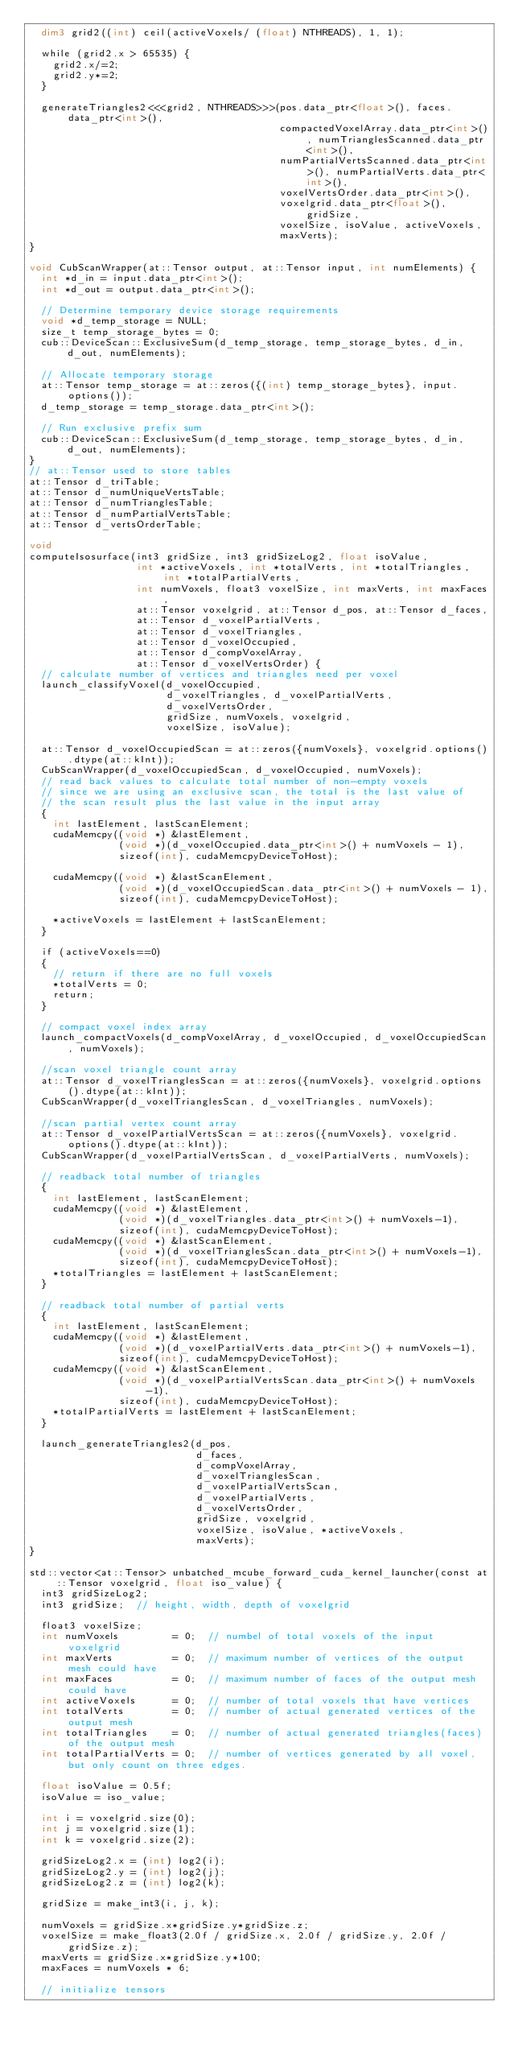Convert code to text. <code><loc_0><loc_0><loc_500><loc_500><_Cuda_>  dim3 grid2((int) ceil(activeVoxels/ (float) NTHREADS), 1, 1);

  while (grid2.x > 65535) {
    grid2.x/=2;
    grid2.y*=2;
  }

  generateTriangles2<<<grid2, NTHREADS>>>(pos.data_ptr<float>(), faces.data_ptr<int>(),
                                          compactedVoxelArray.data_ptr<int>(), numTrianglesScanned.data_ptr<int>(),
                                          numPartialVertsScanned.data_ptr<int>(), numPartialVerts.data_ptr<int>(),
                                          voxelVertsOrder.data_ptr<int>(),
                                          voxelgrid.data_ptr<float>(), gridSize,
                                          voxelSize, isoValue, activeVoxels,
                                          maxVerts);
}

void CubScanWrapper(at::Tensor output, at::Tensor input, int numElements) {
  int *d_in = input.data_ptr<int>();
  int *d_out = output.data_ptr<int>();

  // Determine temporary device storage requirements
  void *d_temp_storage = NULL;
  size_t temp_storage_bytes = 0;
  cub::DeviceScan::ExclusiveSum(d_temp_storage, temp_storage_bytes, d_in, d_out, numElements);

  // Allocate temporary storage
  at::Tensor temp_storage = at::zeros({(int) temp_storage_bytes}, input.options());
  d_temp_storage = temp_storage.data_ptr<int>();

  // Run exclusive prefix sum
  cub::DeviceScan::ExclusiveSum(d_temp_storage, temp_storage_bytes, d_in, d_out, numElements);
}
// at::Tensor used to store tables
at::Tensor d_triTable;
at::Tensor d_numUniqueVertsTable;
at::Tensor d_numTrianglesTable;
at::Tensor d_numPartialVertsTable;
at::Tensor d_vertsOrderTable;

void
computeIsosurface(int3 gridSize, int3 gridSizeLog2, float isoValue,
                  int *activeVoxels, int *totalVerts, int *totalTriangles, int *totalPartialVerts,
                  int numVoxels, float3 voxelSize, int maxVerts, int maxFaces,
                  at::Tensor voxelgrid, at::Tensor d_pos, at::Tensor d_faces,
                  at::Tensor d_voxelPartialVerts,
                  at::Tensor d_voxelTriangles,
                  at::Tensor d_voxelOccupied,
                  at::Tensor d_compVoxelArray,
                  at::Tensor d_voxelVertsOrder) {
  // calculate number of vertices and triangles need per voxel
  launch_classifyVoxel(d_voxelOccupied,
                       d_voxelTriangles, d_voxelPartialVerts,
                       d_voxelVertsOrder,
                       gridSize, numVoxels, voxelgrid,
                       voxelSize, isoValue);
  
  at::Tensor d_voxelOccupiedScan = at::zeros({numVoxels}, voxelgrid.options().dtype(at::kInt));
  CubScanWrapper(d_voxelOccupiedScan, d_voxelOccupied, numVoxels);
  // read back values to calculate total number of non-empty voxels
  // since we are using an exclusive scan, the total is the last value of
  // the scan result plus the last value in the input array
  {
    int lastElement, lastScanElement;
    cudaMemcpy((void *) &lastElement,
               (void *)(d_voxelOccupied.data_ptr<int>() + numVoxels - 1),
               sizeof(int), cudaMemcpyDeviceToHost);
  
    cudaMemcpy((void *) &lastScanElement,
               (void *)(d_voxelOccupiedScan.data_ptr<int>() + numVoxels - 1),
               sizeof(int), cudaMemcpyDeviceToHost);
  
    *activeVoxels = lastElement + lastScanElement;
  }

  if (activeVoxels==0)
  {
    // return if there are no full voxels
    *totalVerts = 0;
    return;
  }

  // compact voxel index array
  launch_compactVoxels(d_compVoxelArray, d_voxelOccupied, d_voxelOccupiedScan, numVoxels);

  //scan voxel triangle count array
  at::Tensor d_voxelTrianglesScan = at::zeros({numVoxels}, voxelgrid.options().dtype(at::kInt));
  CubScanWrapper(d_voxelTrianglesScan, d_voxelTriangles, numVoxels);

  //scan partial vertex count array
  at::Tensor d_voxelPartialVertsScan = at::zeros({numVoxels}, voxelgrid.options().dtype(at::kInt));
  CubScanWrapper(d_voxelPartialVertsScan, d_voxelPartialVerts, numVoxels);

  // readback total number of triangles
  {
    int lastElement, lastScanElement;
    cudaMemcpy((void *) &lastElement,
               (void *)(d_voxelTriangles.data_ptr<int>() + numVoxels-1),
               sizeof(int), cudaMemcpyDeviceToHost);
    cudaMemcpy((void *) &lastScanElement,
               (void *)(d_voxelTrianglesScan.data_ptr<int>() + numVoxels-1),
               sizeof(int), cudaMemcpyDeviceToHost);
    *totalTriangles = lastElement + lastScanElement;
  }

  // readback total number of partial verts
  {
    int lastElement, lastScanElement;
    cudaMemcpy((void *) &lastElement,
               (void *)(d_voxelPartialVerts.data_ptr<int>() + numVoxels-1),
               sizeof(int), cudaMemcpyDeviceToHost);
    cudaMemcpy((void *) &lastScanElement,
               (void *)(d_voxelPartialVertsScan.data_ptr<int>() + numVoxels-1),
               sizeof(int), cudaMemcpyDeviceToHost);
    *totalPartialVerts = lastElement + lastScanElement;
  }

  launch_generateTriangles2(d_pos,
                            d_faces,
                            d_compVoxelArray,
                            d_voxelTrianglesScan,
                            d_voxelPartialVertsScan,
                            d_voxelPartialVerts,
                            d_voxelVertsOrder,
                            gridSize, voxelgrid,
                            voxelSize, isoValue, *activeVoxels,
                            maxVerts);
}

std::vector<at::Tensor> unbatched_mcube_forward_cuda_kernel_launcher(const at::Tensor voxelgrid, float iso_value) {
  int3 gridSizeLog2;
  int3 gridSize;  // height, width, depth of voxelgrid

  float3 voxelSize;
  int numVoxels         = 0;  // numbel of total voxels of the input voxelgrid
  int maxVerts          = 0;  // maximum number of vertices of the output mesh could have
  int maxFaces          = 0;  // maximum number of faces of the output mesh could have
  int activeVoxels      = 0;  // number of total voxels that have vertices
  int totalVerts        = 0;  // number of actual generated vertices of the output mesh
  int totalTriangles    = 0;  // number of actual generated triangles(faces) of the output mesh
  int totalPartialVerts = 0;  // number of vertices generated by all voxel, but only count on three edges.

  float isoValue = 0.5f;
  isoValue = iso_value;

  int i = voxelgrid.size(0);
  int j = voxelgrid.size(1);
  int k = voxelgrid.size(2);

  gridSizeLog2.x = (int) log2(i);
  gridSizeLog2.y = (int) log2(j);
  gridSizeLog2.z = (int) log2(k);

  gridSize = make_int3(i, j, k);

  numVoxels = gridSize.x*gridSize.y*gridSize.z;
  voxelSize = make_float3(2.0f / gridSize.x, 2.0f / gridSize.y, 2.0f / gridSize.z);
  maxVerts = gridSize.x*gridSize.y*100;
  maxFaces = numVoxels * 6;

  // initialize tensors</code> 